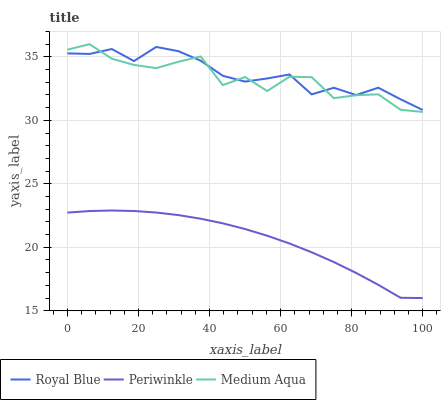Does Periwinkle have the minimum area under the curve?
Answer yes or no. Yes. Does Royal Blue have the maximum area under the curve?
Answer yes or no. Yes. Does Royal Blue have the minimum area under the curve?
Answer yes or no. No. Does Periwinkle have the maximum area under the curve?
Answer yes or no. No. Is Periwinkle the smoothest?
Answer yes or no. Yes. Is Medium Aqua the roughest?
Answer yes or no. Yes. Is Royal Blue the smoothest?
Answer yes or no. No. Is Royal Blue the roughest?
Answer yes or no. No. Does Periwinkle have the lowest value?
Answer yes or no. Yes. Does Royal Blue have the lowest value?
Answer yes or no. No. Does Medium Aqua have the highest value?
Answer yes or no. Yes. Does Royal Blue have the highest value?
Answer yes or no. No. Is Periwinkle less than Medium Aqua?
Answer yes or no. Yes. Is Medium Aqua greater than Periwinkle?
Answer yes or no. Yes. Does Royal Blue intersect Medium Aqua?
Answer yes or no. Yes. Is Royal Blue less than Medium Aqua?
Answer yes or no. No. Is Royal Blue greater than Medium Aqua?
Answer yes or no. No. Does Periwinkle intersect Medium Aqua?
Answer yes or no. No. 